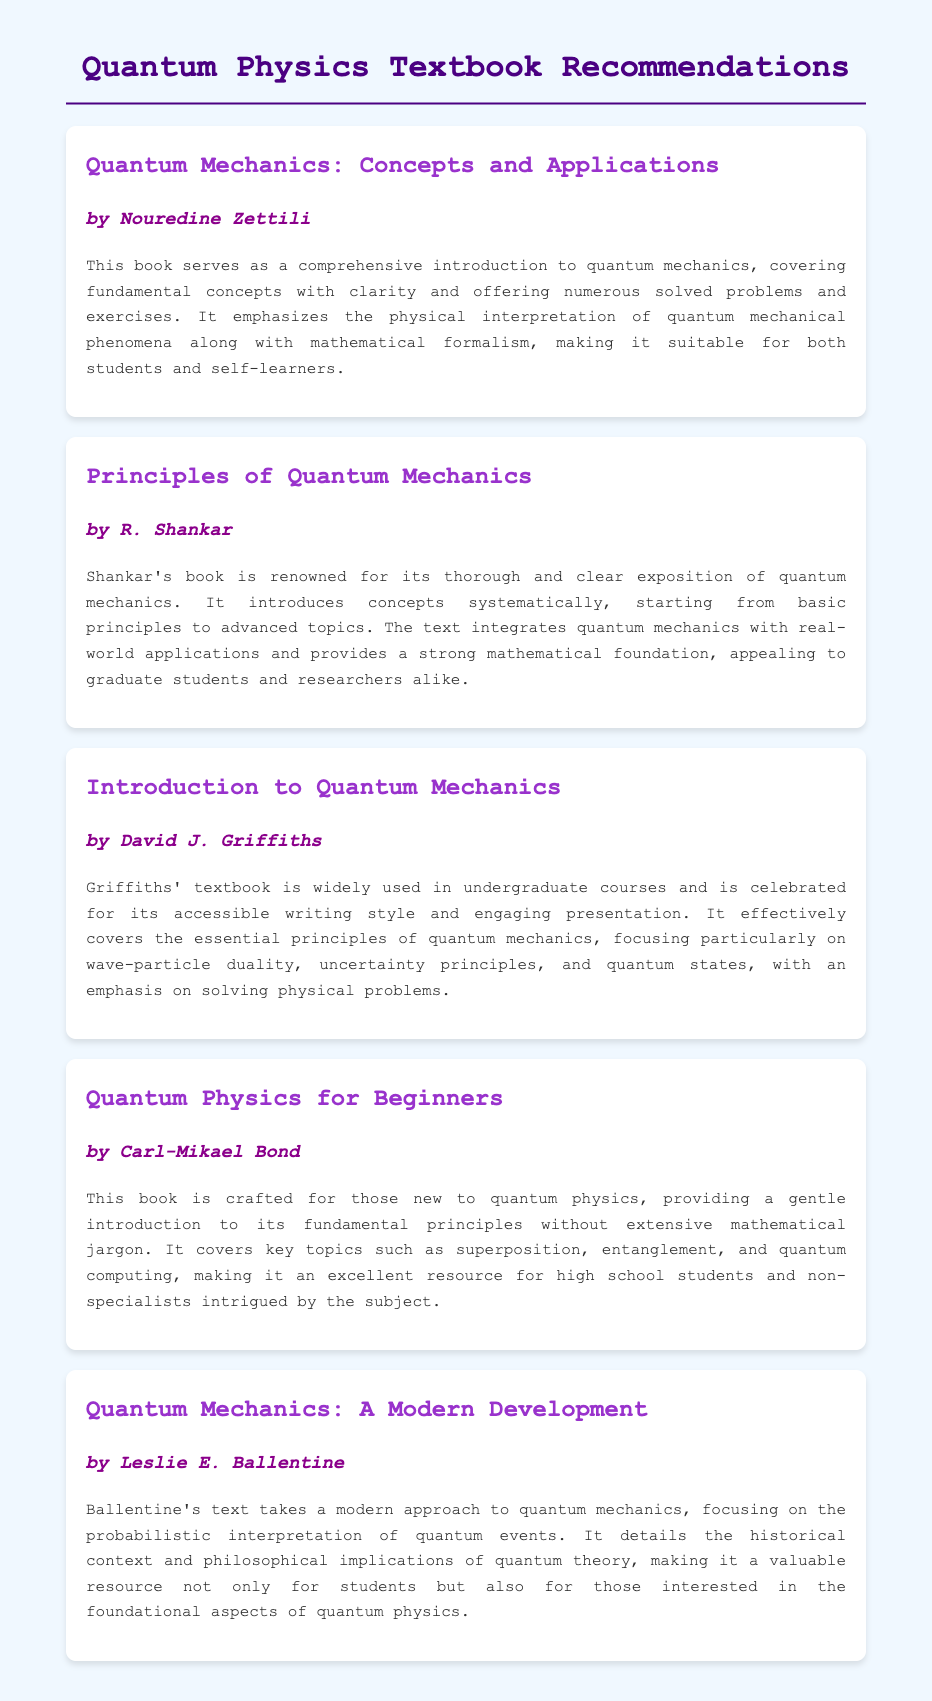What is the title of the first book? The first book listed in the document is titled "Quantum Mechanics: Concepts and Applications."
Answer: Quantum Mechanics: Concepts and Applications Who is the author of "Principles of Quantum Mechanics"? The author of "Principles of Quantum Mechanics" is R. Shankar.
Answer: R. Shankar How many books are recommended in the document? The document includes a total of five recommended books on quantum physics.
Answer: Five What fundamental concept is emphasized in David J. Griffiths' textbook? Griffiths' textbook emphasizes essential principles, particularly wave-particle duality, uncertainty principles, and quantum states.
Answer: Wave-particle duality, uncertainty principles, and quantum states Which book is suitable for high school students? "Quantum Physics for Beginners" by Carl-Mikael Bond is crafted for those new to quantum physics and is suitable for high school students.
Answer: Quantum Physics for Beginners What approach does Leslie E. Ballentine's text take? Ballentine's text takes a modern approach focusing on the probabilistic interpretation of quantum events.
Answer: Probabilistic interpretation How does "Quantum Mechanics: A Modern Development" address historical context? It details the historical context and philosophical implications of quantum theory, making it valuable for understanding foundational aspects.
Answer: Historical context and philosophical implications What is the focus of "Quantum Mechanics: Concepts and Applications"? The book covers fundamental concepts with clarity, offering solved problems and exercises, emphasizing the physical interpretation of phenomena.
Answer: Comprehensive introduction to quantum mechanics 